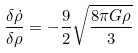Convert formula to latex. <formula><loc_0><loc_0><loc_500><loc_500>\frac { \delta \dot { \rho } } { \delta \rho } = - \frac { 9 } { 2 } \sqrt { \frac { 8 \pi G \rho } { 3 } }</formula> 